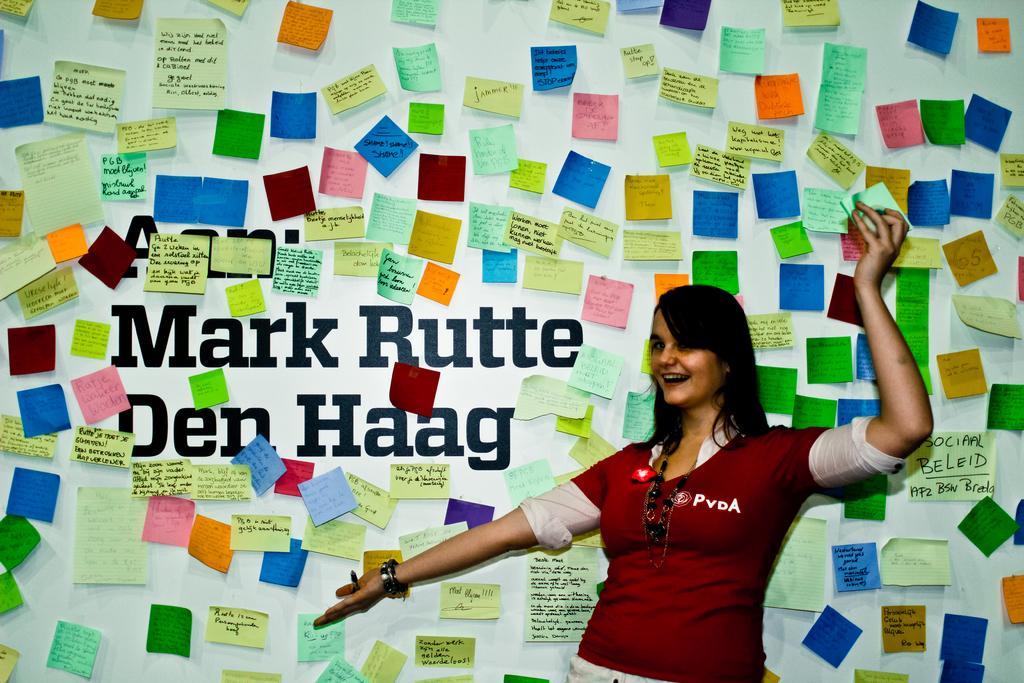Describe this image in one or two sentences. In the picture I can see a person wearing maroon color T-shirt and chain is smiling and standing on the right side of the image. In the background, I can see many papers on which some text is written are passed to the wall. 